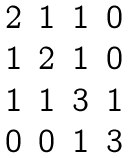Convert formula to latex. <formula><loc_0><loc_0><loc_500><loc_500>\begin{matrix} 2 & 1 & 1 & 0 \\ 1 & 2 & 1 & 0 \\ 1 & 1 & 3 & 1 \\ 0 & 0 & 1 & 3 \end{matrix}</formula> 